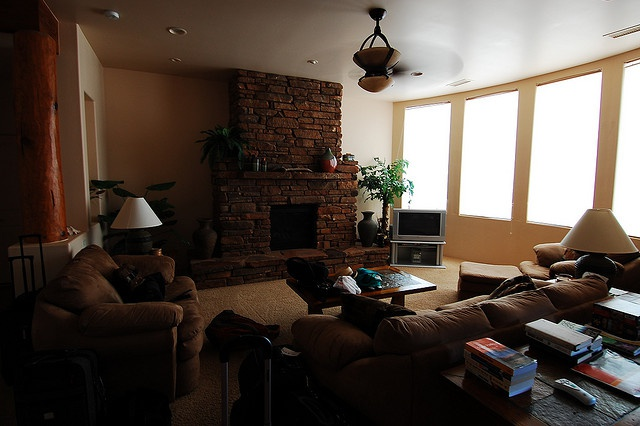Describe the objects in this image and their specific colors. I can see couch in black, maroon, and gray tones, couch in black, maroon, and gray tones, chair in black, tan, and maroon tones, potted plant in black, white, gray, and darkgray tones, and dining table in black, white, maroon, and gray tones in this image. 